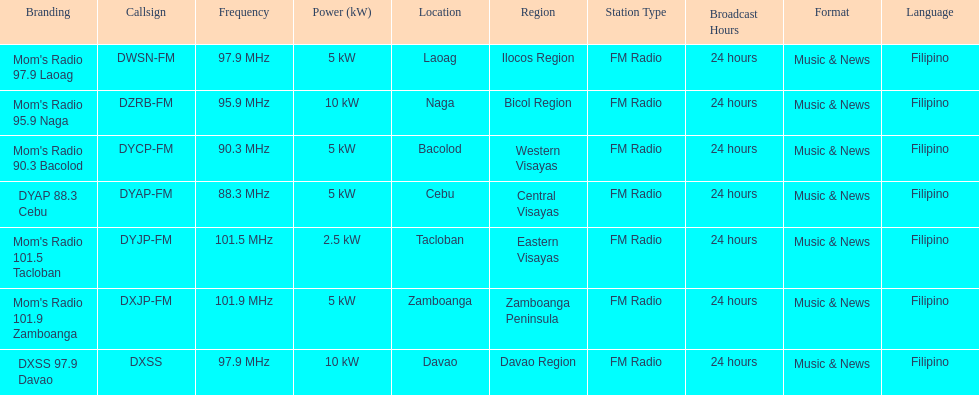How many stations broadcast with a power of 5kw? 4. 